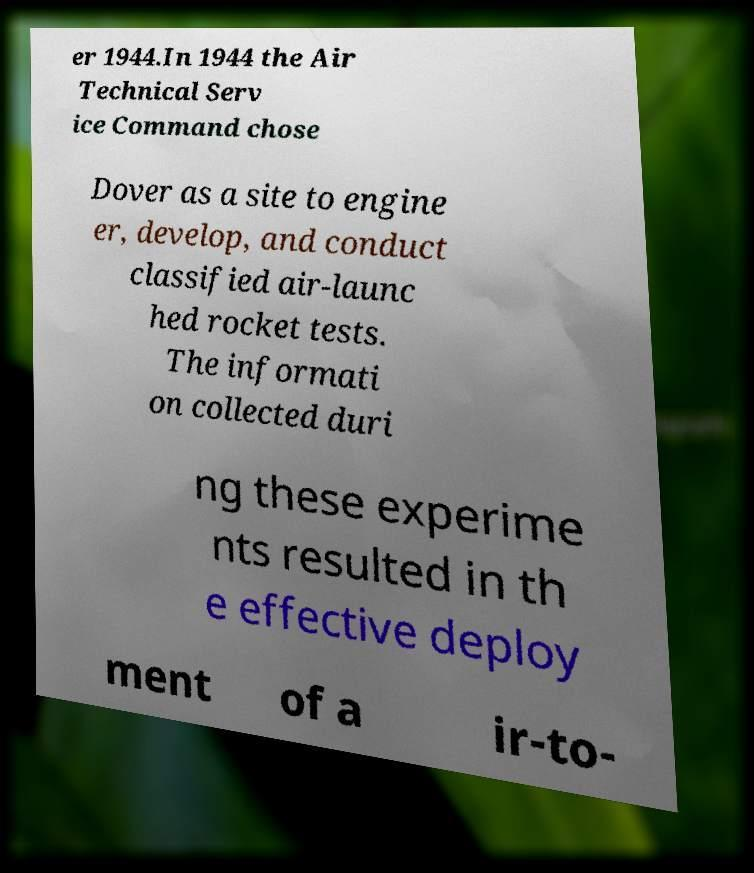Please identify and transcribe the text found in this image. er 1944.In 1944 the Air Technical Serv ice Command chose Dover as a site to engine er, develop, and conduct classified air-launc hed rocket tests. The informati on collected duri ng these experime nts resulted in th e effective deploy ment of a ir-to- 